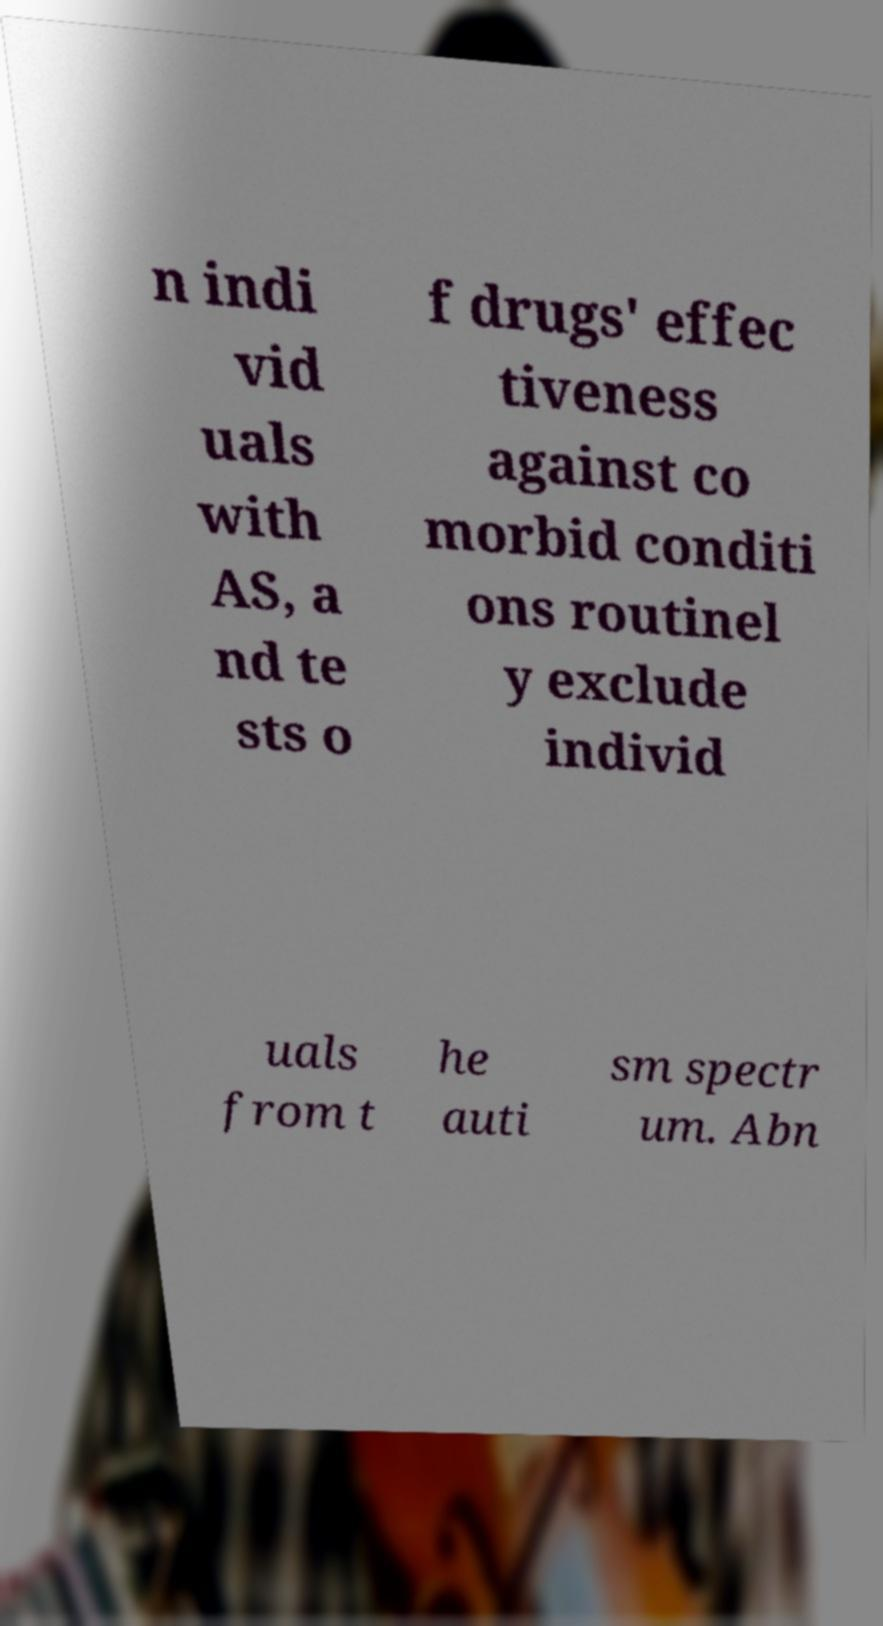Please identify and transcribe the text found in this image. n indi vid uals with AS, a nd te sts o f drugs' effec tiveness against co morbid conditi ons routinel y exclude individ uals from t he auti sm spectr um. Abn 